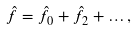Convert formula to latex. <formula><loc_0><loc_0><loc_500><loc_500>\hat { f } = \hat { f } _ { 0 } + \hat { f } _ { 2 } + \dots ,</formula> 